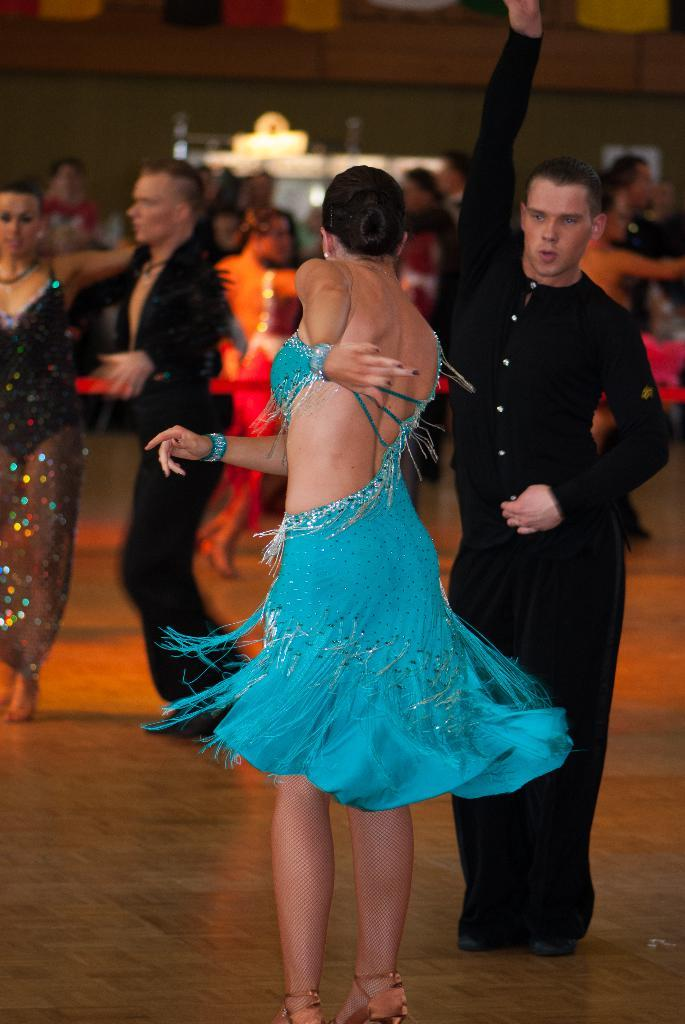How many people are in the image? There is a group of people in the image. What can be observed about the clothing of the people in the image? The people are wearing different color dresses. What can be seen in the background of the image? There are objects visible in the background of the image. How would you describe the appearance of the background? The background appears to be blurred. How many balloons are being held by the people in the image? There is no mention of balloons in the image; the people are wearing different color dresses. Can you tell me which toe is the most prominent on the people's feet in the image? There is no information about the people's feet or toes in the image. 